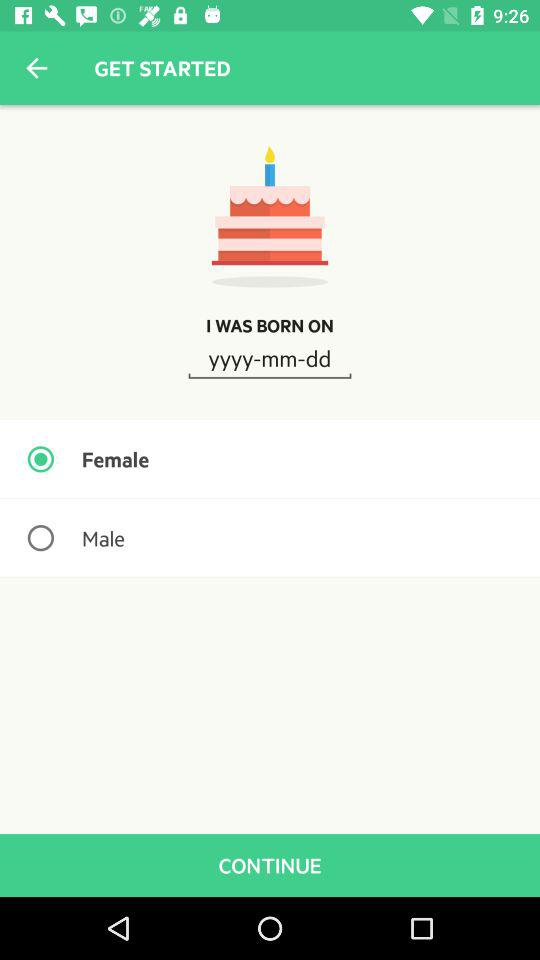Which format is given to enter the date? The given format to enter the date is yyyy-mm-dd. 